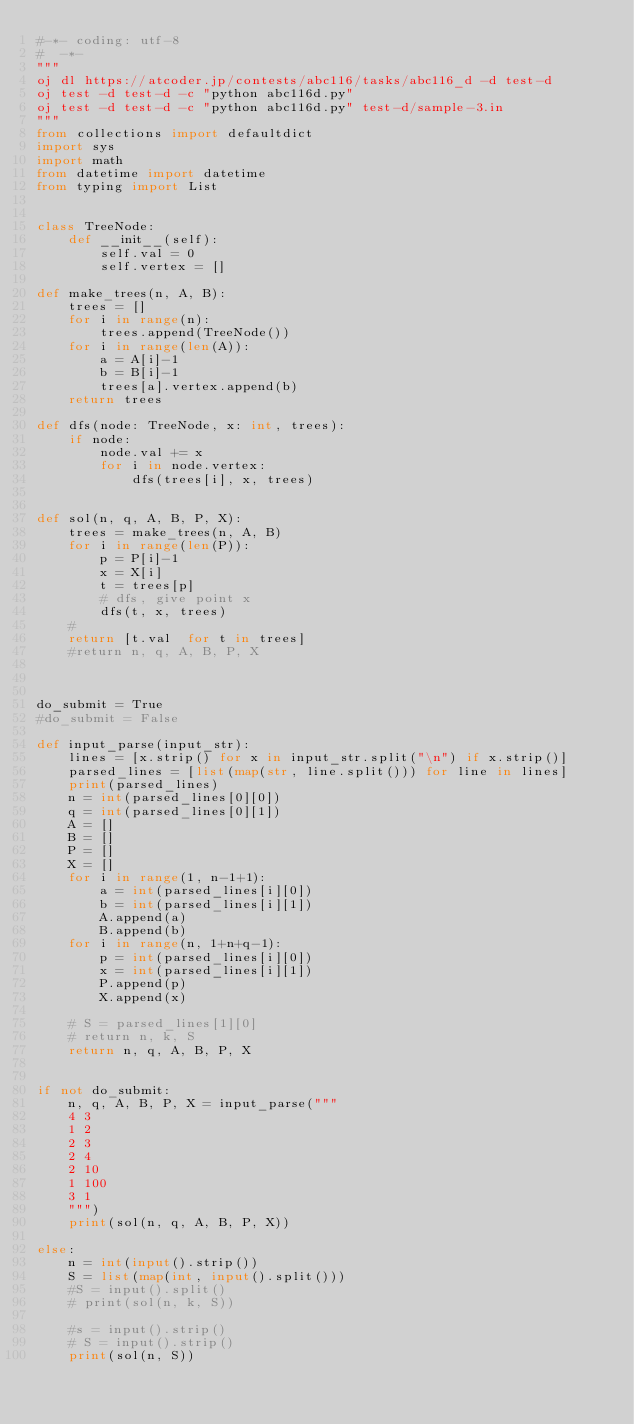Convert code to text. <code><loc_0><loc_0><loc_500><loc_500><_Python_>#-*- coding: utf-8
#  -*-
"""
oj dl https://atcoder.jp/contests/abc116/tasks/abc116_d -d test-d
oj test -d test-d -c "python abc116d.py"
oj test -d test-d -c "python abc116d.py" test-d/sample-3.in
"""
from collections import defaultdict
import sys
import math
from datetime import datetime
from typing import List


class TreeNode:
    def __init__(self):
        self.val = 0
        self.vertex = []

def make_trees(n, A, B):
    trees = []
    for i in range(n):
        trees.append(TreeNode())
    for i in range(len(A)):
        a = A[i]-1
        b = B[i]-1
        trees[a].vertex.append(b)
    return trees

def dfs(node: TreeNode, x: int, trees):
    if node:
        node.val += x
        for i in node.vertex:
            dfs(trees[i], x, trees)


def sol(n, q, A, B, P, X):
    trees = make_trees(n, A, B)
    for i in range(len(P)):
        p = P[i]-1
        x = X[i]
        t = trees[p]
        # dfs, give point x
        dfs(t, x, trees)
    #
    return [t.val  for t in trees]
    #return n, q, A, B, P, X



do_submit = True
#do_submit = False

def input_parse(input_str):
    lines = [x.strip() for x in input_str.split("\n") if x.strip()]
    parsed_lines = [list(map(str, line.split())) for line in lines]
    print(parsed_lines)
    n = int(parsed_lines[0][0])
    q = int(parsed_lines[0][1])
    A = []
    B = []
    P = []
    X = []
    for i in range(1, n-1+1):
        a = int(parsed_lines[i][0])
        b = int(parsed_lines[i][1])
        A.append(a)
        B.append(b)
    for i in range(n, 1+n+q-1):
        p = int(parsed_lines[i][0])
        x = int(parsed_lines[i][1])
        P.append(p)
        X.append(x)

    # S = parsed_lines[1][0]
    # return n, k, S
    return n, q, A, B, P, X


if not do_submit:
    n, q, A, B, P, X = input_parse("""
    4 3
    1 2
    2 3
    2 4
    2 10
    1 100
    3 1
    """)
    print(sol(n, q, A, B, P, X))

else:
    n = int(input().strip())
    S = list(map(int, input().split()))
    #S = input().split()
    # print(sol(n, k, S))

    #s = input().strip()
    # S = input().strip()
    print(sol(n, S))

</code> 